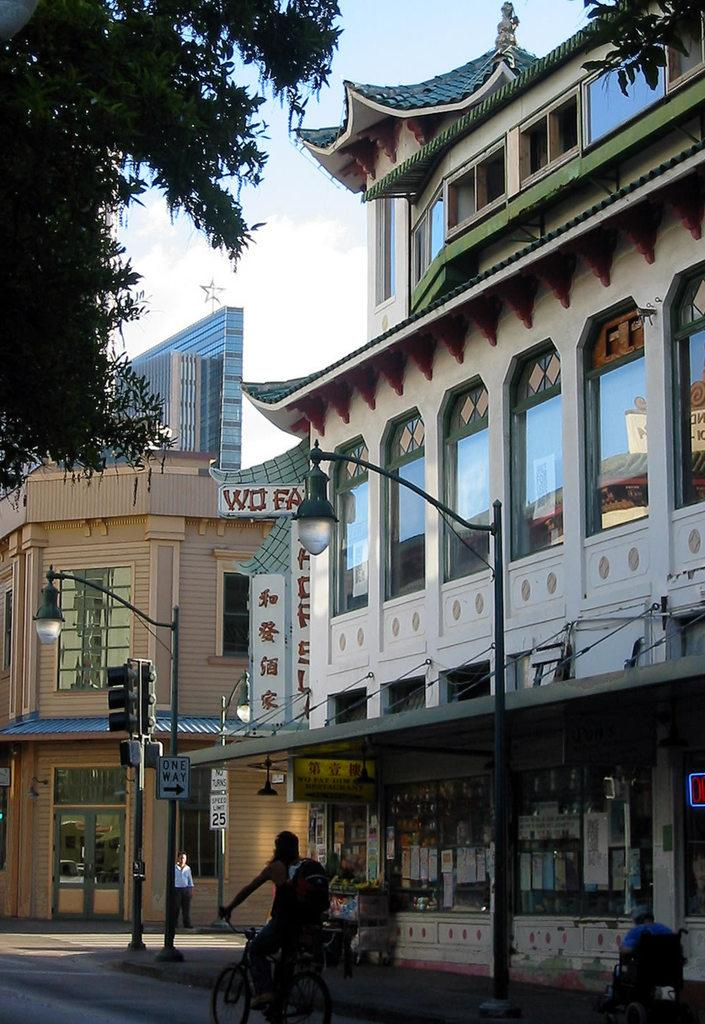What type of structures can be seen in the image? There are buildings in the image. What feature do the buildings have? The buildings have glass windows. What type of establishments are present in the image? There are stores in the image. What can be seen on the buildings or stores in the image? Sign boards are visible in the image. What traffic control device is present in the image? A traffic signal is present. What type of street furniture is visible in the image? Light poles are in the image. What type of vegetation is present in the image? Trees are present in the image. What is the color of the sky in the image? The sky is blue and white in color. How many chairs are placed around the stew in the image? There is no stew or chairs present in the image. What type of range can be seen in the image? There is no range present in the image. 